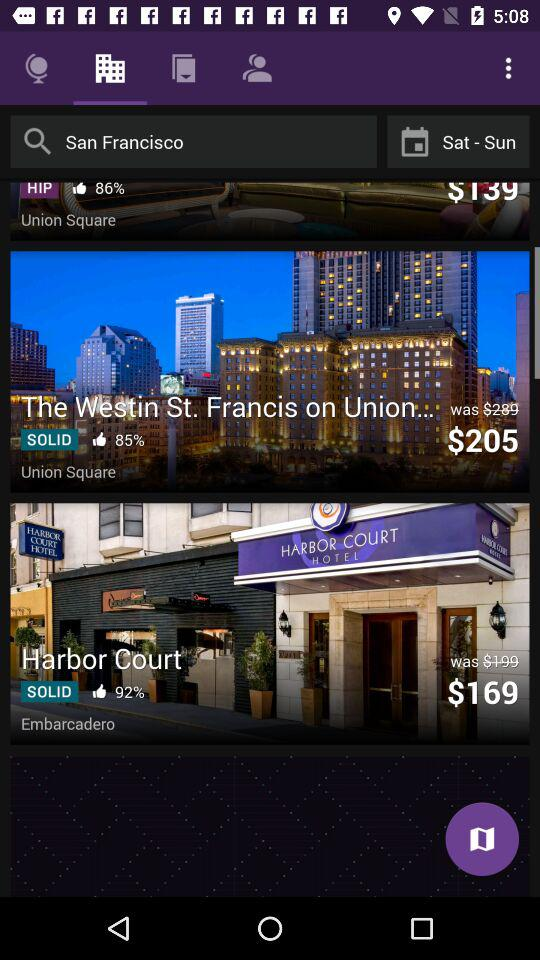What is the entered location? The entered location is San Francisco. 